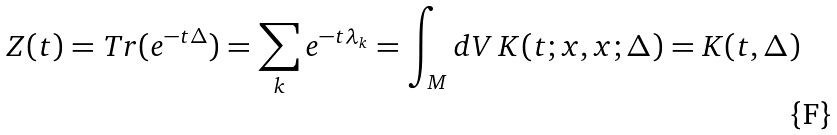Convert formula to latex. <formula><loc_0><loc_0><loc_500><loc_500>Z ( t ) = T r ( e ^ { - t \Delta } ) = \sum _ { k } e ^ { - t \lambda _ { k } } = \int _ { M } d V \, K ( t ; x , x ; \Delta ) = K ( t , \Delta )</formula> 